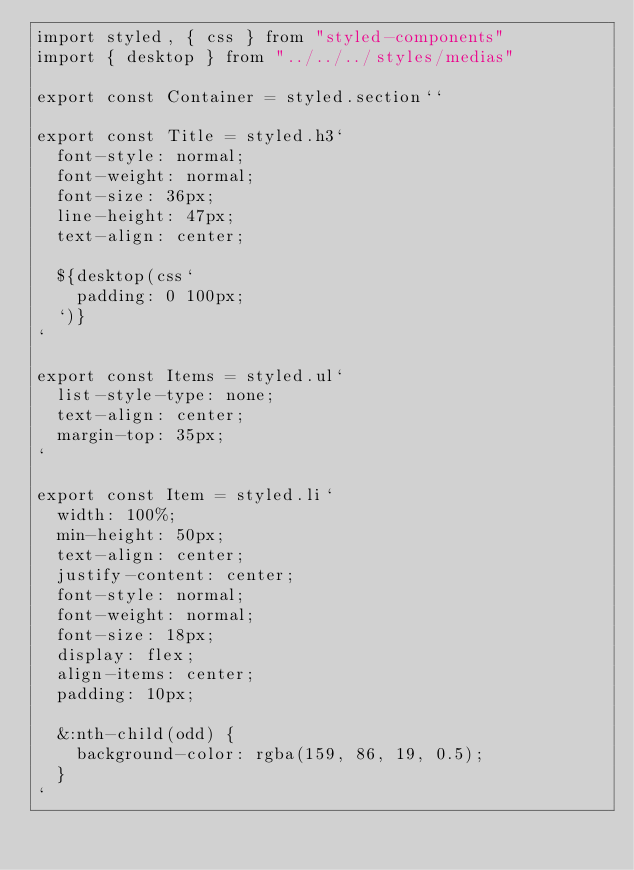Convert code to text. <code><loc_0><loc_0><loc_500><loc_500><_JavaScript_>import styled, { css } from "styled-components"
import { desktop } from "../../../styles/medias"

export const Container = styled.section``

export const Title = styled.h3`
  font-style: normal;
  font-weight: normal;
  font-size: 36px;
  line-height: 47px;
  text-align: center;

  ${desktop(css`
    padding: 0 100px;
  `)}
`

export const Items = styled.ul`
  list-style-type: none;
  text-align: center;
  margin-top: 35px;
`

export const Item = styled.li`
  width: 100%;
  min-height: 50px;
  text-align: center;
  justify-content: center;
  font-style: normal;
  font-weight: normal;
  font-size: 18px;
  display: flex;
  align-items: center;
  padding: 10px;

  &:nth-child(odd) {
    background-color: rgba(159, 86, 19, 0.5);
  }
`
</code> 